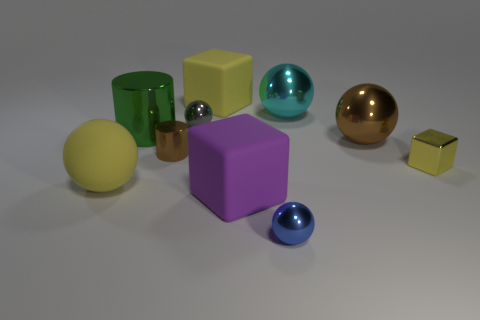Subtract all rubber balls. How many balls are left? 4 Subtract all brown balls. How many balls are left? 4 Subtract 1 cubes. How many cubes are left? 2 Subtract all gray cylinders. How many yellow cubes are left? 2 Add 3 brown metallic cylinders. How many brown metallic cylinders are left? 4 Add 2 yellow shiny blocks. How many yellow shiny blocks exist? 3 Subtract 1 brown balls. How many objects are left? 9 Subtract all blocks. How many objects are left? 7 Subtract all cyan balls. Subtract all blue cubes. How many balls are left? 4 Subtract all big purple things. Subtract all small blue objects. How many objects are left? 8 